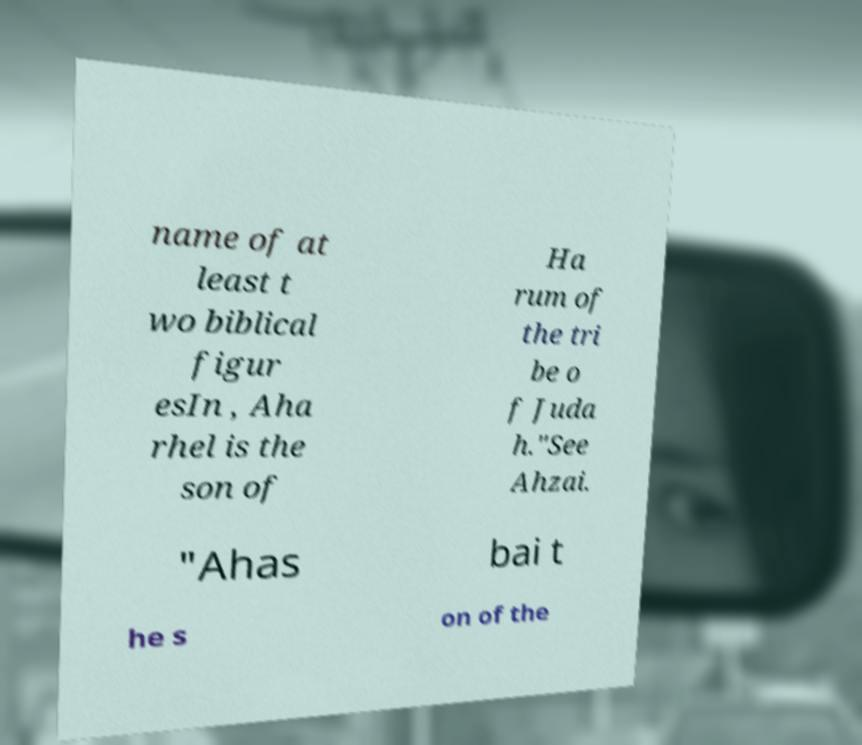What messages or text are displayed in this image? I need them in a readable, typed format. name of at least t wo biblical figur esIn , Aha rhel is the son of Ha rum of the tri be o f Juda h."See Ahzai. "Ahas bai t he s on of the 